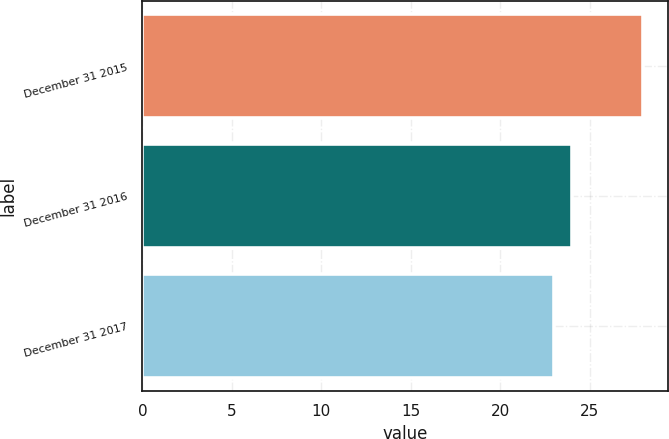<chart> <loc_0><loc_0><loc_500><loc_500><bar_chart><fcel>December 31 2015<fcel>December 31 2016<fcel>December 31 2017<nl><fcel>28<fcel>24<fcel>23<nl></chart> 